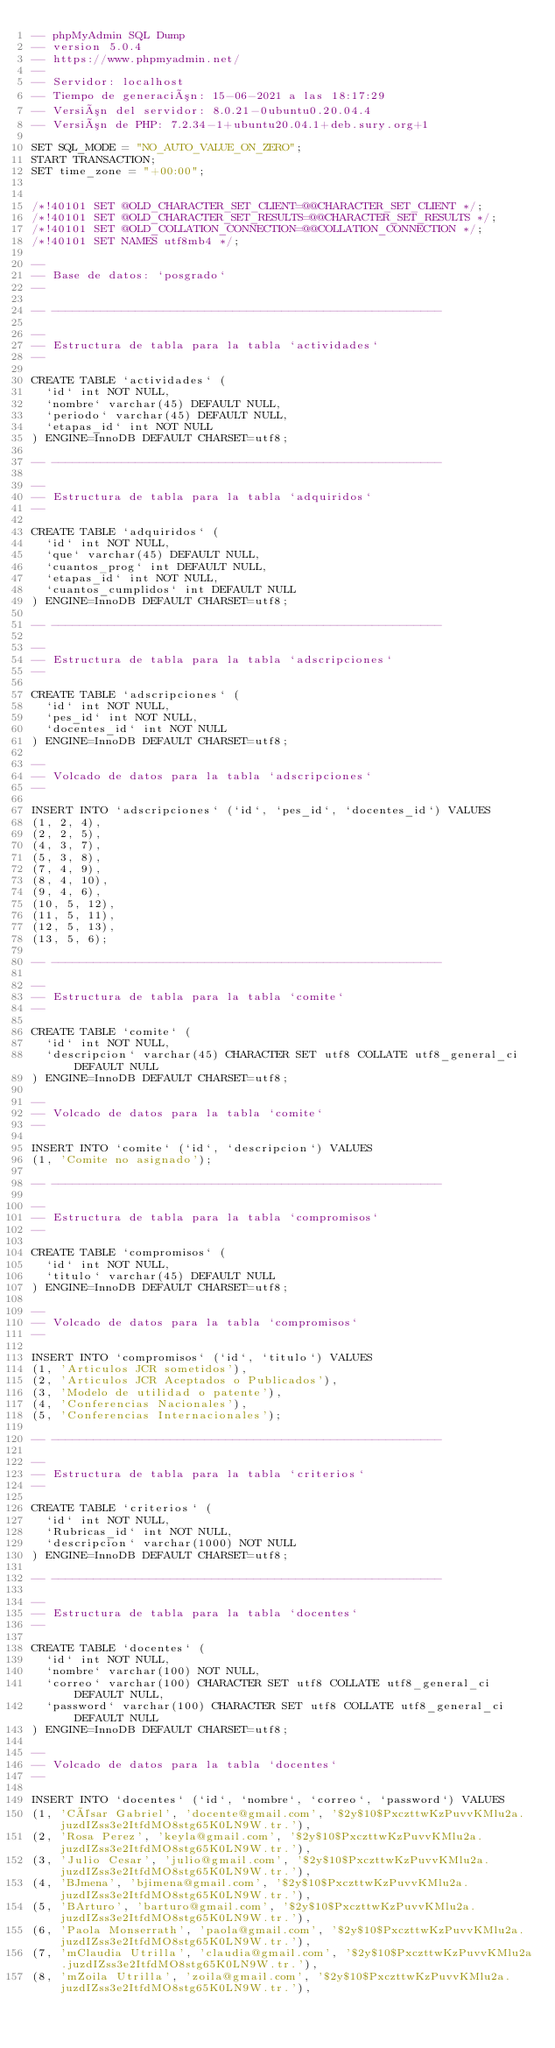<code> <loc_0><loc_0><loc_500><loc_500><_SQL_>-- phpMyAdmin SQL Dump
-- version 5.0.4
-- https://www.phpmyadmin.net/
--
-- Servidor: localhost
-- Tiempo de generación: 15-06-2021 a las 18:17:29
-- Versión del servidor: 8.0.21-0ubuntu0.20.04.4
-- Versión de PHP: 7.2.34-1+ubuntu20.04.1+deb.sury.org+1

SET SQL_MODE = "NO_AUTO_VALUE_ON_ZERO";
START TRANSACTION;
SET time_zone = "+00:00";


/*!40101 SET @OLD_CHARACTER_SET_CLIENT=@@CHARACTER_SET_CLIENT */;
/*!40101 SET @OLD_CHARACTER_SET_RESULTS=@@CHARACTER_SET_RESULTS */;
/*!40101 SET @OLD_COLLATION_CONNECTION=@@COLLATION_CONNECTION */;
/*!40101 SET NAMES utf8mb4 */;

--
-- Base de datos: `posgrado`
--

-- --------------------------------------------------------

--
-- Estructura de tabla para la tabla `actividades`
--

CREATE TABLE `actividades` (
  `id` int NOT NULL,
  `nombre` varchar(45) DEFAULT NULL,
  `periodo` varchar(45) DEFAULT NULL,
  `etapas_id` int NOT NULL
) ENGINE=InnoDB DEFAULT CHARSET=utf8;

-- --------------------------------------------------------

--
-- Estructura de tabla para la tabla `adquiridos`
--

CREATE TABLE `adquiridos` (
  `id` int NOT NULL,
  `que` varchar(45) DEFAULT NULL,
  `cuantos_prog` int DEFAULT NULL,
  `etapas_id` int NOT NULL,
  `cuantos_cumplidos` int DEFAULT NULL
) ENGINE=InnoDB DEFAULT CHARSET=utf8;

-- --------------------------------------------------------

--
-- Estructura de tabla para la tabla `adscripciones`
--

CREATE TABLE `adscripciones` (
  `id` int NOT NULL,
  `pes_id` int NOT NULL,
  `docentes_id` int NOT NULL
) ENGINE=InnoDB DEFAULT CHARSET=utf8;

--
-- Volcado de datos para la tabla `adscripciones`
--

INSERT INTO `adscripciones` (`id`, `pes_id`, `docentes_id`) VALUES
(1, 2, 4),
(2, 2, 5),
(4, 3, 7),
(5, 3, 8),
(7, 4, 9),
(8, 4, 10),
(9, 4, 6),
(10, 5, 12),
(11, 5, 11),
(12, 5, 13),
(13, 5, 6);

-- --------------------------------------------------------

--
-- Estructura de tabla para la tabla `comite`
--

CREATE TABLE `comite` (
  `id` int NOT NULL,
  `descripcion` varchar(45) CHARACTER SET utf8 COLLATE utf8_general_ci DEFAULT NULL
) ENGINE=InnoDB DEFAULT CHARSET=utf8;

--
-- Volcado de datos para la tabla `comite`
--

INSERT INTO `comite` (`id`, `descripcion`) VALUES
(1, 'Comite no asignado');

-- --------------------------------------------------------

--
-- Estructura de tabla para la tabla `compromisos`
--

CREATE TABLE `compromisos` (
  `id` int NOT NULL,
  `titulo` varchar(45) DEFAULT NULL
) ENGINE=InnoDB DEFAULT CHARSET=utf8;

--
-- Volcado de datos para la tabla `compromisos`
--

INSERT INTO `compromisos` (`id`, `titulo`) VALUES
(1, 'Articulos JCR sometidos'),
(2, 'Articulos JCR Aceptados o Publicados'),
(3, 'Modelo de utilidad o patente'),
(4, 'Conferencias Nacionales'),
(5, 'Conferencias Internacionales');

-- --------------------------------------------------------

--
-- Estructura de tabla para la tabla `criterios`
--

CREATE TABLE `criterios` (
  `id` int NOT NULL,
  `Rubricas_id` int NOT NULL,
  `descripcion` varchar(1000) NOT NULL
) ENGINE=InnoDB DEFAULT CHARSET=utf8;

-- --------------------------------------------------------

--
-- Estructura de tabla para la tabla `docentes`
--

CREATE TABLE `docentes` (
  `id` int NOT NULL,
  `nombre` varchar(100) NOT NULL,
  `correo` varchar(100) CHARACTER SET utf8 COLLATE utf8_general_ci DEFAULT NULL,
  `password` varchar(100) CHARACTER SET utf8 COLLATE utf8_general_ci DEFAULT NULL
) ENGINE=InnoDB DEFAULT CHARSET=utf8;

--
-- Volcado de datos para la tabla `docentes`
--

INSERT INTO `docentes` (`id`, `nombre`, `correo`, `password`) VALUES
(1, 'César Gabriel', 'docente@gmail.com', '$2y$10$PxczttwKzPuvvKMlu2a.juzdIZss3e2ItfdMO8stg65K0LN9W.tr.'),
(2, 'Rosa Perez', 'keyla@gmail.com', '$2y$10$PxczttwKzPuvvKMlu2a.juzdIZss3e2ItfdMO8stg65K0LN9W.tr.'),
(3, 'Julio Cesar', 'julio@gmail.com', '$2y$10$PxczttwKzPuvvKMlu2a.juzdIZss3e2ItfdMO8stg65K0LN9W.tr.'),
(4, 'BJmena', 'bjimena@gmail.com', '$2y$10$PxczttwKzPuvvKMlu2a.juzdIZss3e2ItfdMO8stg65K0LN9W.tr.'),
(5, 'BArturo', 'barturo@gmail.com', '$2y$10$PxczttwKzPuvvKMlu2a.juzdIZss3e2ItfdMO8stg65K0LN9W.tr.'),
(6, 'Paola Monserrath', 'paola@gmail.com', '$2y$10$PxczttwKzPuvvKMlu2a.juzdIZss3e2ItfdMO8stg65K0LN9W.tr.'),
(7, 'mClaudia Utrilla', 'claudia@gmail.com', '$2y$10$PxczttwKzPuvvKMlu2a.juzdIZss3e2ItfdMO8stg65K0LN9W.tr.'),
(8, 'mZoila Utrilla', 'zoila@gmail.com', '$2y$10$PxczttwKzPuvvKMlu2a.juzdIZss3e2ItfdMO8stg65K0LN9W.tr.'),</code> 